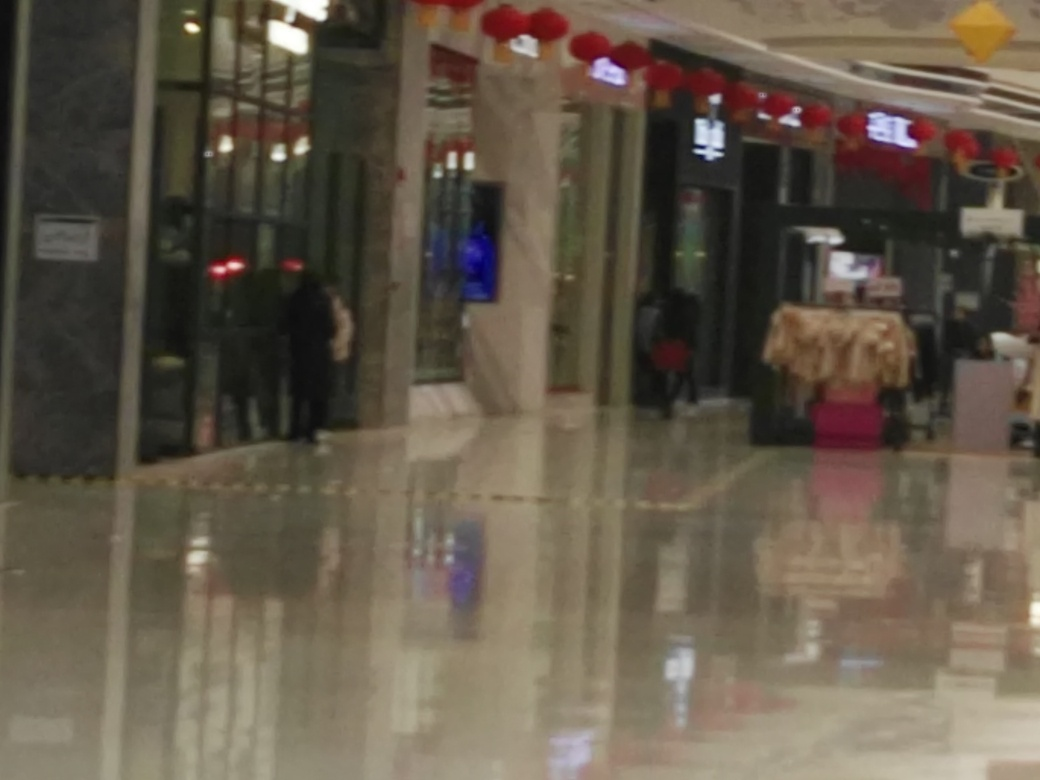What time of day does this photo seem to be taken? Although the photo's blurriness makes it difficult to determine the exact time, the interior lighting does not give specific clues about the time of day, as the lighting in commercial spaces like this is often consistent throughout operating hours. However, the lack of shadows or natural light suggests it may be taken in the evening or at a time when daylight does not prominently influence the interior lighting. 